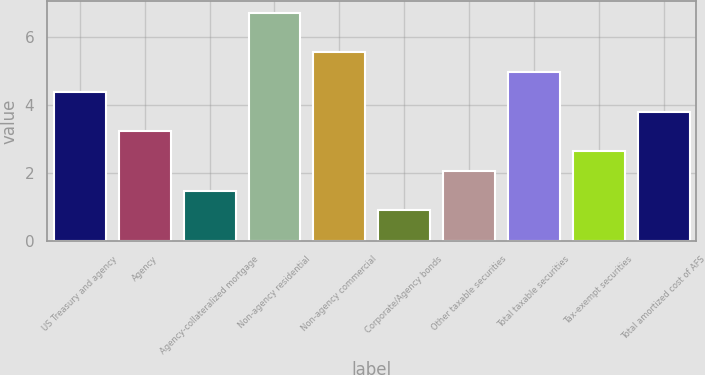<chart> <loc_0><loc_0><loc_500><loc_500><bar_chart><fcel>US Treasury and agency<fcel>Agency<fcel>Agency-collateralized mortgage<fcel>Non-agency residential<fcel>Non-agency commercial<fcel>Corporate/Agency bonds<fcel>Other taxable securities<fcel>Total taxable securities<fcel>Tax-exempt securities<fcel>Total amortized cost of AFS<nl><fcel>4.38<fcel>3.22<fcel>1.48<fcel>6.7<fcel>5.54<fcel>0.9<fcel>2.06<fcel>4.96<fcel>2.64<fcel>3.8<nl></chart> 